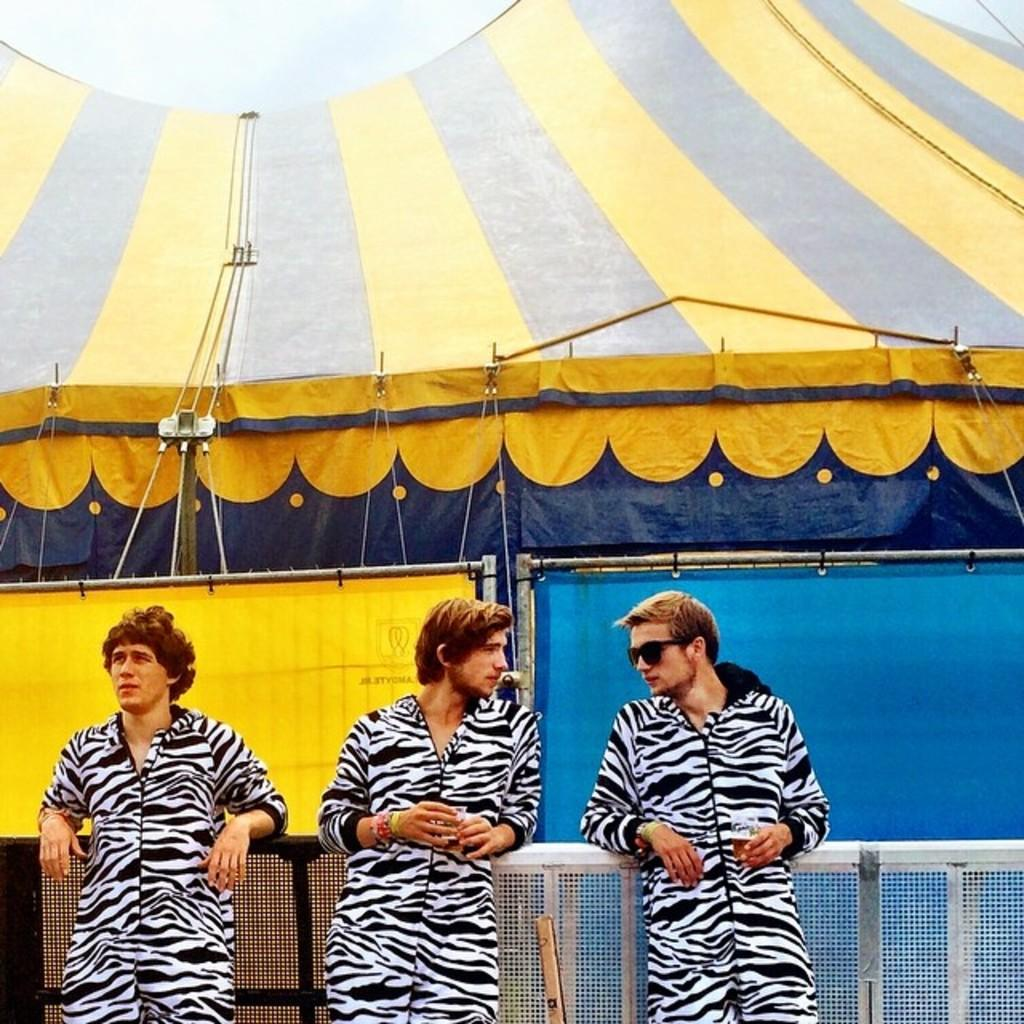How many men are in the image? There are three men in the image. What are the men wearing? The men are wearing zebra costumes. Where are the men positioned in the image? The men are standing in the front of the image. Can you describe another person visible in the image? There is a girl visible in the image. What type of structure can be seen in the background of the image? There is a big yellow tent in the image. What force is being applied to the men in the image? There is no force being applied to the men in the image; they are standing still. How does the girl look in the image? The description of the girl's appearance is not mentioned in the provided facts, so we cannot answer this question. 